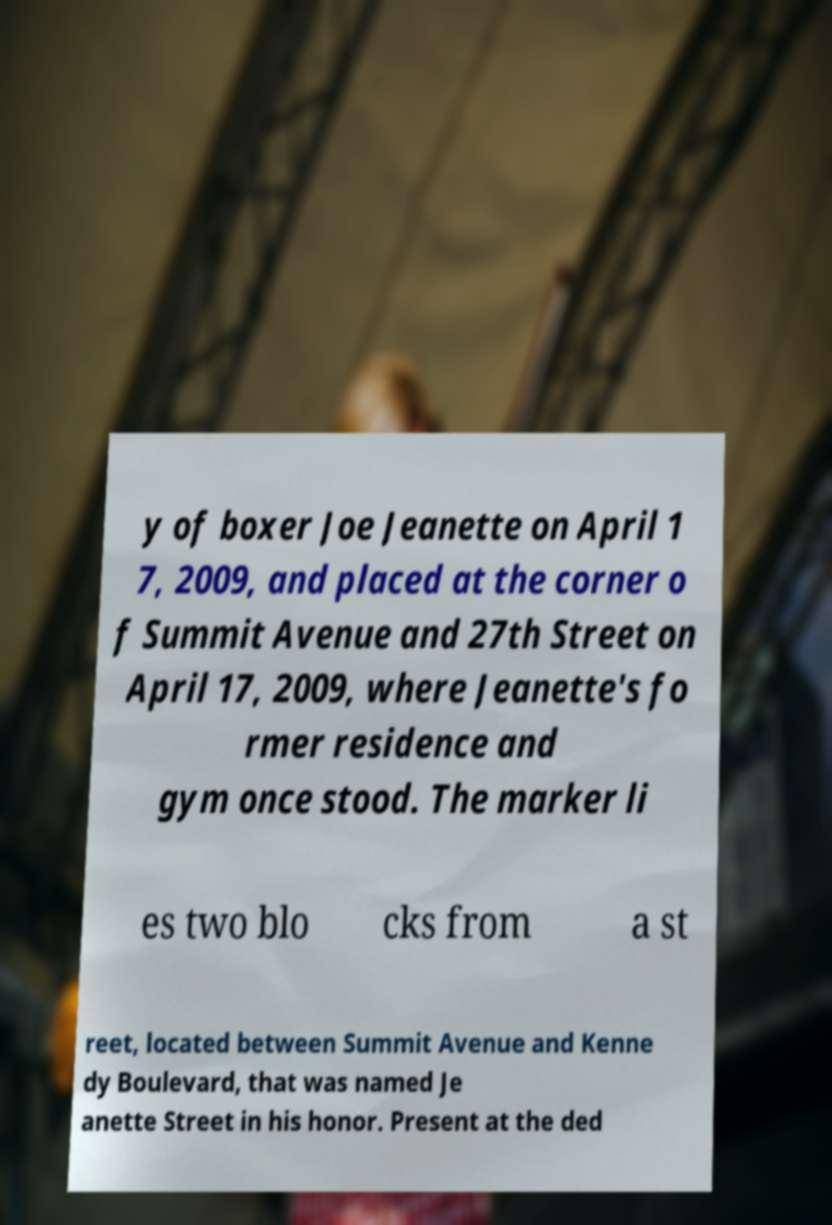Can you read and provide the text displayed in the image?This photo seems to have some interesting text. Can you extract and type it out for me? y of boxer Joe Jeanette on April 1 7, 2009, and placed at the corner o f Summit Avenue and 27th Street on April 17, 2009, where Jeanette's fo rmer residence and gym once stood. The marker li es two blo cks from a st reet, located between Summit Avenue and Kenne dy Boulevard, that was named Je anette Street in his honor. Present at the ded 